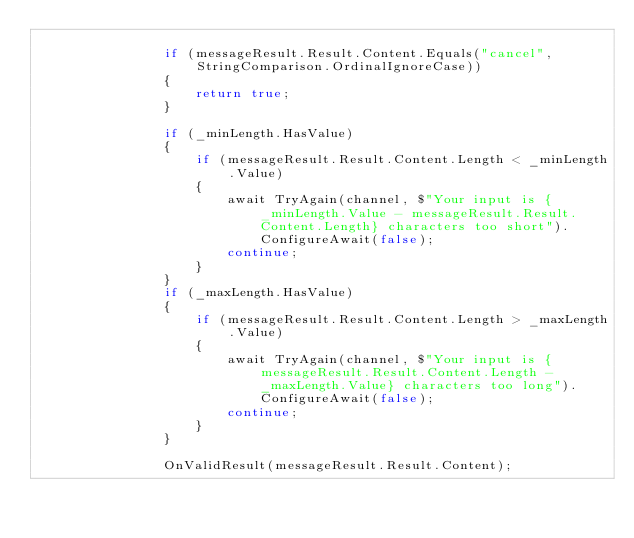Convert code to text. <code><loc_0><loc_0><loc_500><loc_500><_C#_>
                if (messageResult.Result.Content.Equals("cancel", StringComparison.OrdinalIgnoreCase))
                {
                    return true;
                } 

                if (_minLength.HasValue)
                {
                    if (messageResult.Result.Content.Length < _minLength.Value)
                    {
                        await TryAgain(channel, $"Your input is {_minLength.Value - messageResult.Result.Content.Length} characters too short").ConfigureAwait(false);
                        continue;
                    }
                }
                if (_maxLength.HasValue)
                {
                    if (messageResult.Result.Content.Length > _maxLength.Value)
                    {
                        await TryAgain(channel, $"Your input is {messageResult.Result.Content.Length - _maxLength.Value} characters too long").ConfigureAwait(false);
                        continue;
                    }
                }

                OnValidResult(messageResult.Result.Content);
</code> 